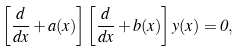Convert formula to latex. <formula><loc_0><loc_0><loc_500><loc_500>\left [ \frac { d } { d x } + a ( x ) \right ] \left [ \frac { d } { d x } + b ( x ) \right ] y ( x ) = 0 ,</formula> 